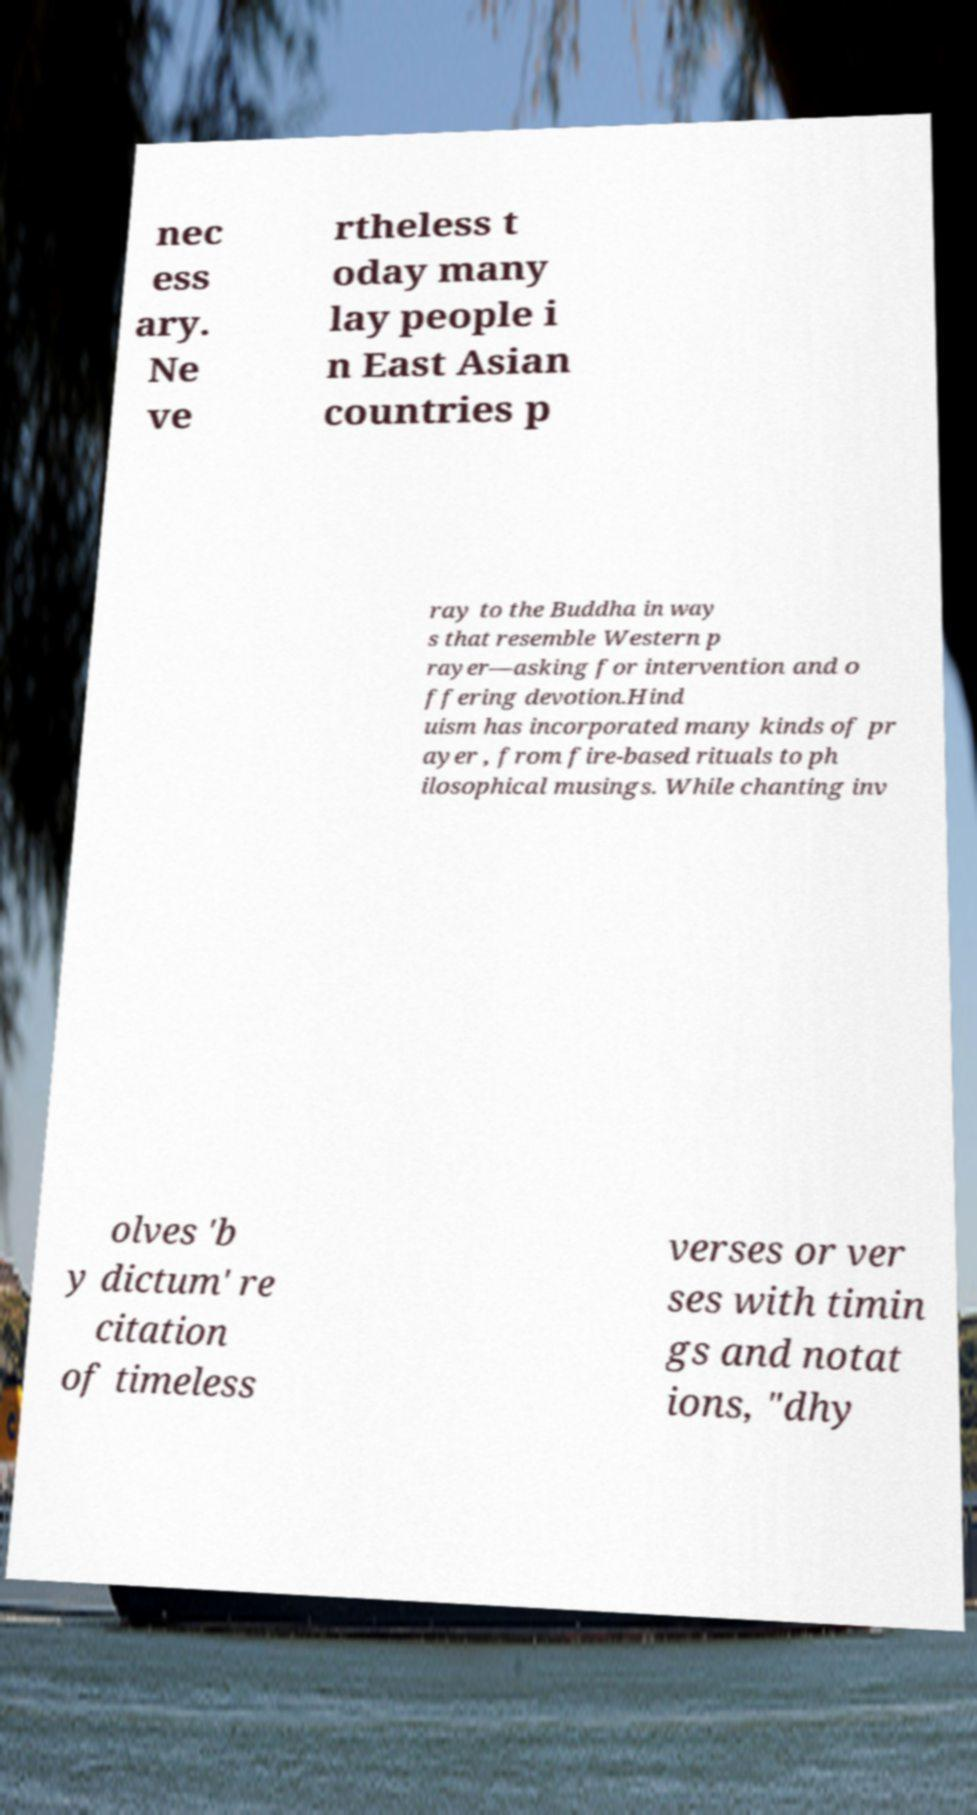Please identify and transcribe the text found in this image. nec ess ary. Ne ve rtheless t oday many lay people i n East Asian countries p ray to the Buddha in way s that resemble Western p rayer—asking for intervention and o ffering devotion.Hind uism has incorporated many kinds of pr ayer , from fire-based rituals to ph ilosophical musings. While chanting inv olves 'b y dictum' re citation of timeless verses or ver ses with timin gs and notat ions, "dhy 